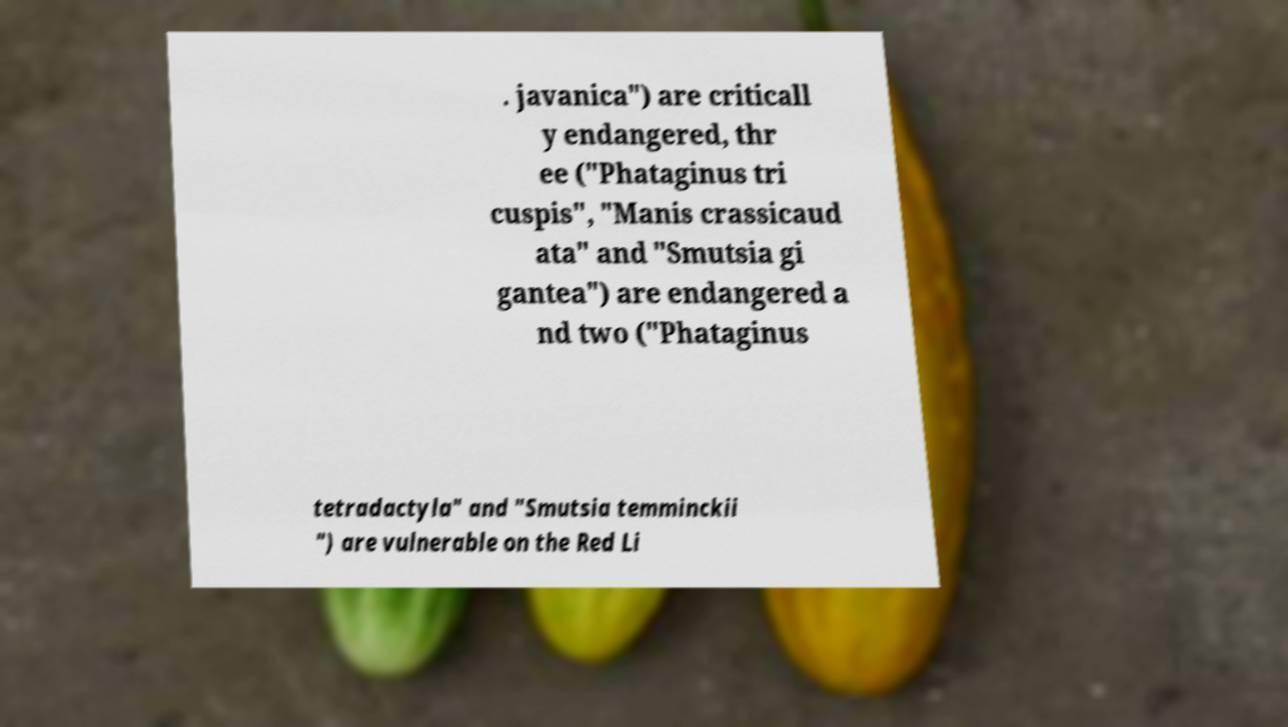Could you extract and type out the text from this image? . javanica") are criticall y endangered, thr ee ("Phataginus tri cuspis", "Manis crassicaud ata" and "Smutsia gi gantea") are endangered a nd two ("Phataginus tetradactyla" and "Smutsia temminckii ") are vulnerable on the Red Li 